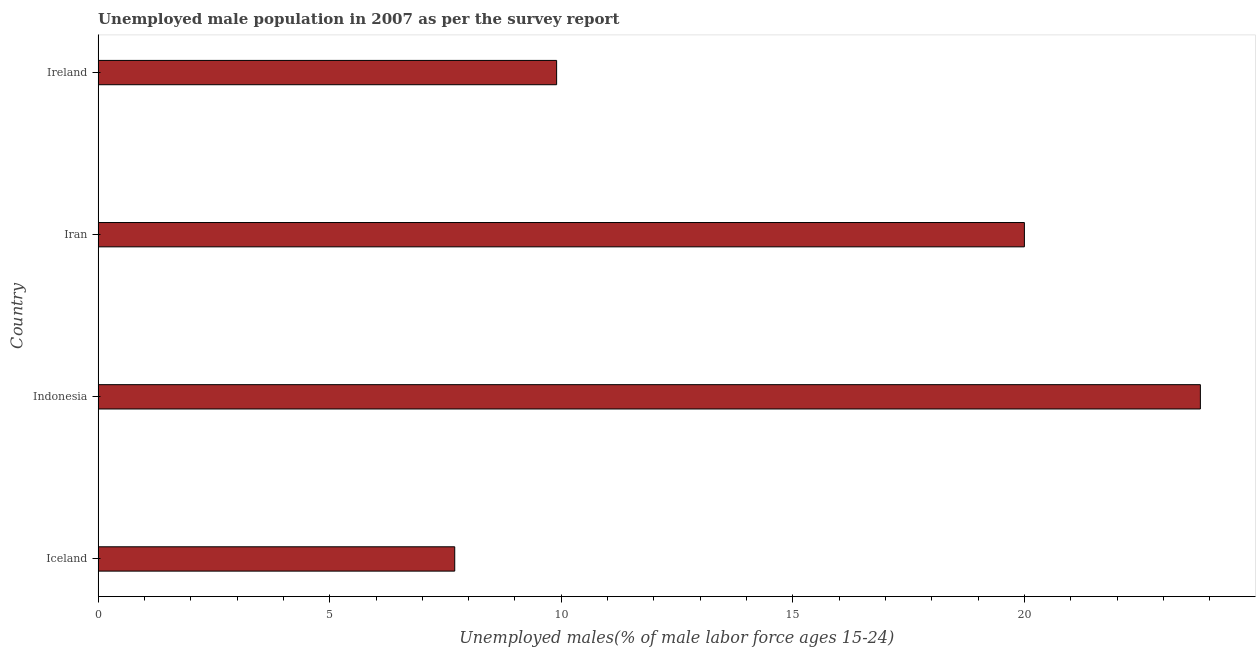Does the graph contain any zero values?
Provide a succinct answer. No. What is the title of the graph?
Give a very brief answer. Unemployed male population in 2007 as per the survey report. What is the label or title of the X-axis?
Offer a terse response. Unemployed males(% of male labor force ages 15-24). What is the unemployed male youth in Ireland?
Keep it short and to the point. 9.9. Across all countries, what is the maximum unemployed male youth?
Provide a short and direct response. 23.8. Across all countries, what is the minimum unemployed male youth?
Ensure brevity in your answer.  7.7. In which country was the unemployed male youth maximum?
Make the answer very short. Indonesia. In which country was the unemployed male youth minimum?
Give a very brief answer. Iceland. What is the sum of the unemployed male youth?
Provide a short and direct response. 61.4. What is the average unemployed male youth per country?
Keep it short and to the point. 15.35. What is the median unemployed male youth?
Offer a terse response. 14.95. What is the ratio of the unemployed male youth in Iran to that in Ireland?
Provide a succinct answer. 2.02. What is the difference between the highest and the second highest unemployed male youth?
Provide a short and direct response. 3.8. How many bars are there?
Your answer should be compact. 4. Are all the bars in the graph horizontal?
Give a very brief answer. Yes. How many countries are there in the graph?
Give a very brief answer. 4. Are the values on the major ticks of X-axis written in scientific E-notation?
Provide a short and direct response. No. What is the Unemployed males(% of male labor force ages 15-24) of Iceland?
Keep it short and to the point. 7.7. What is the Unemployed males(% of male labor force ages 15-24) of Indonesia?
Your response must be concise. 23.8. What is the Unemployed males(% of male labor force ages 15-24) of Iran?
Provide a short and direct response. 20. What is the Unemployed males(% of male labor force ages 15-24) in Ireland?
Your answer should be compact. 9.9. What is the difference between the Unemployed males(% of male labor force ages 15-24) in Iceland and Indonesia?
Offer a very short reply. -16.1. What is the difference between the Unemployed males(% of male labor force ages 15-24) in Iceland and Iran?
Make the answer very short. -12.3. What is the difference between the Unemployed males(% of male labor force ages 15-24) in Indonesia and Iran?
Offer a terse response. 3.8. What is the difference between the Unemployed males(% of male labor force ages 15-24) in Indonesia and Ireland?
Your answer should be very brief. 13.9. What is the difference between the Unemployed males(% of male labor force ages 15-24) in Iran and Ireland?
Ensure brevity in your answer.  10.1. What is the ratio of the Unemployed males(% of male labor force ages 15-24) in Iceland to that in Indonesia?
Offer a very short reply. 0.32. What is the ratio of the Unemployed males(% of male labor force ages 15-24) in Iceland to that in Iran?
Offer a terse response. 0.39. What is the ratio of the Unemployed males(% of male labor force ages 15-24) in Iceland to that in Ireland?
Offer a very short reply. 0.78. What is the ratio of the Unemployed males(% of male labor force ages 15-24) in Indonesia to that in Iran?
Provide a short and direct response. 1.19. What is the ratio of the Unemployed males(% of male labor force ages 15-24) in Indonesia to that in Ireland?
Your answer should be very brief. 2.4. What is the ratio of the Unemployed males(% of male labor force ages 15-24) in Iran to that in Ireland?
Provide a short and direct response. 2.02. 